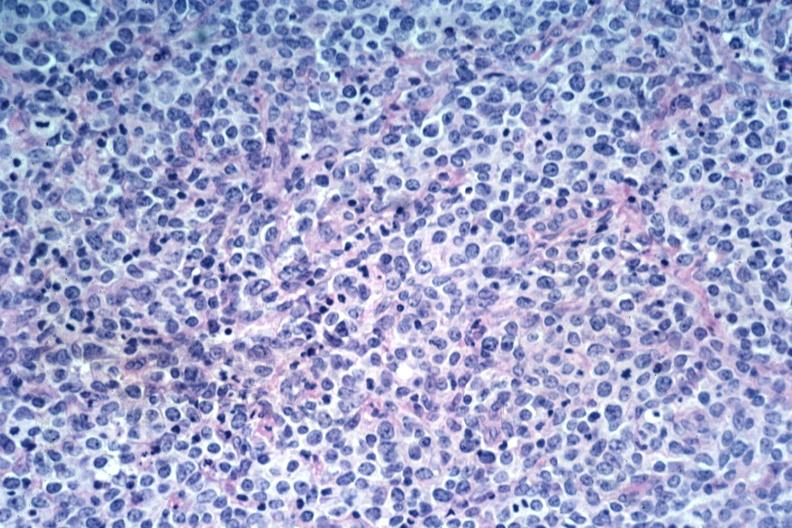what does this image show?
Answer the question using a single word or phrase. Large cell lymphoma 